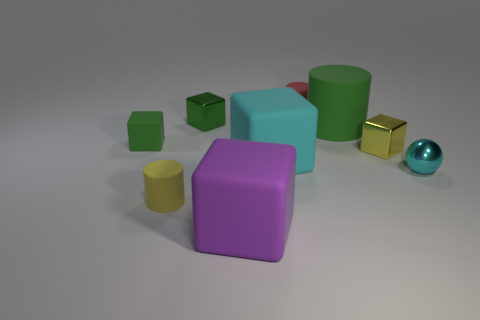What is the shape of the tiny yellow object that is the same material as the large purple object?
Your answer should be compact. Cylinder. Is the shape of the small red matte thing the same as the large purple rubber object?
Ensure brevity in your answer.  No. The big matte cylinder has what color?
Provide a succinct answer. Green. What number of things are either large metallic spheres or cyan rubber things?
Your answer should be compact. 1. Are there fewer large rubber objects that are in front of the big purple thing than gray rubber blocks?
Offer a terse response. No. Is the number of purple cubes in front of the sphere greater than the number of purple objects that are to the right of the big purple matte object?
Keep it short and to the point. Yes. Is there anything else of the same color as the large matte cylinder?
Ensure brevity in your answer.  Yes. What is the material of the block that is in front of the small sphere?
Your answer should be compact. Rubber. Is the ball the same size as the purple matte block?
Give a very brief answer. No. What number of other things are there of the same size as the cyan block?
Give a very brief answer. 2. 